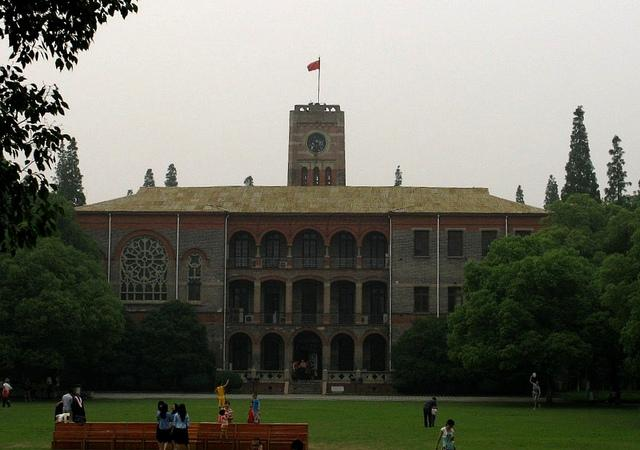What type of building is this most probably looking at the people in the courtyard? Please explain your reasoning. school. This is most likely a college campus with students. 